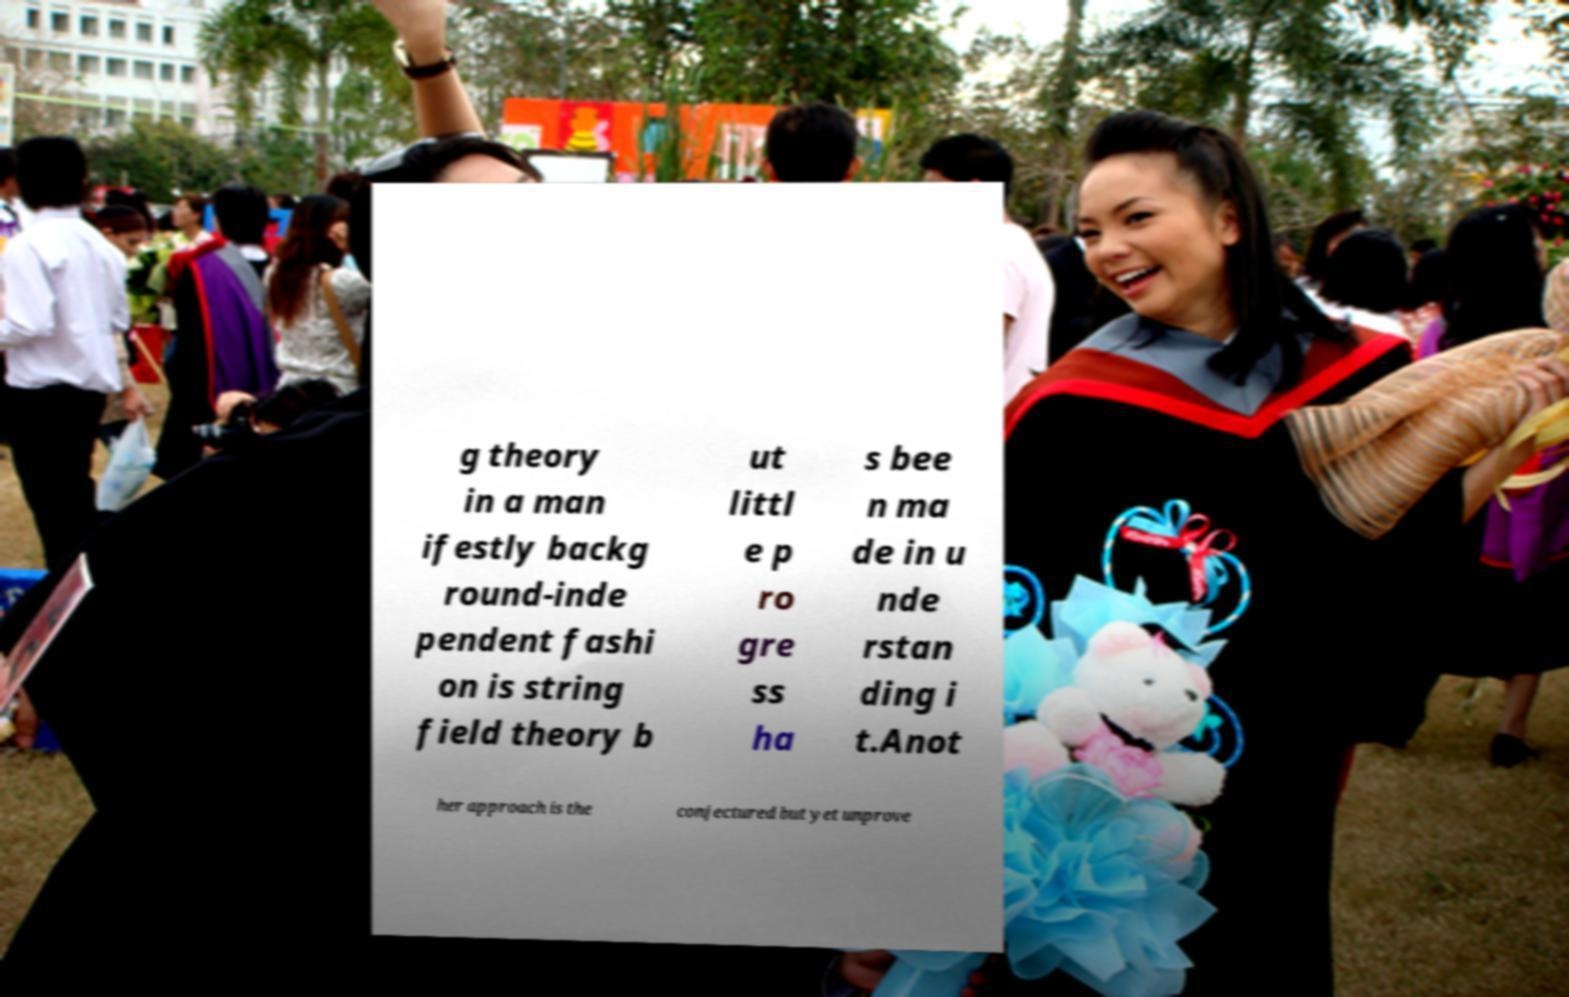Could you extract and type out the text from this image? g theory in a man ifestly backg round-inde pendent fashi on is string field theory b ut littl e p ro gre ss ha s bee n ma de in u nde rstan ding i t.Anot her approach is the conjectured but yet unprove 